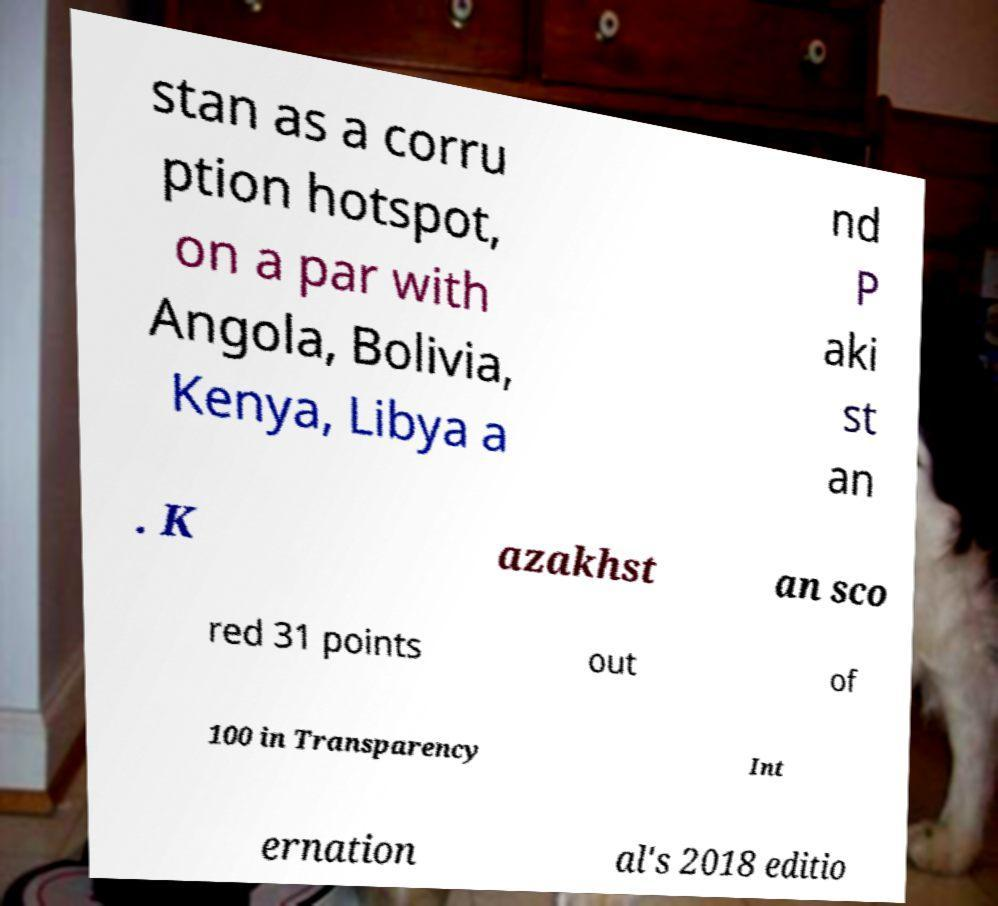Can you read and provide the text displayed in the image?This photo seems to have some interesting text. Can you extract and type it out for me? stan as a corru ption hotspot, on a par with Angola, Bolivia, Kenya, Libya a nd P aki st an . K azakhst an sco red 31 points out of 100 in Transparency Int ernation al's 2018 editio 